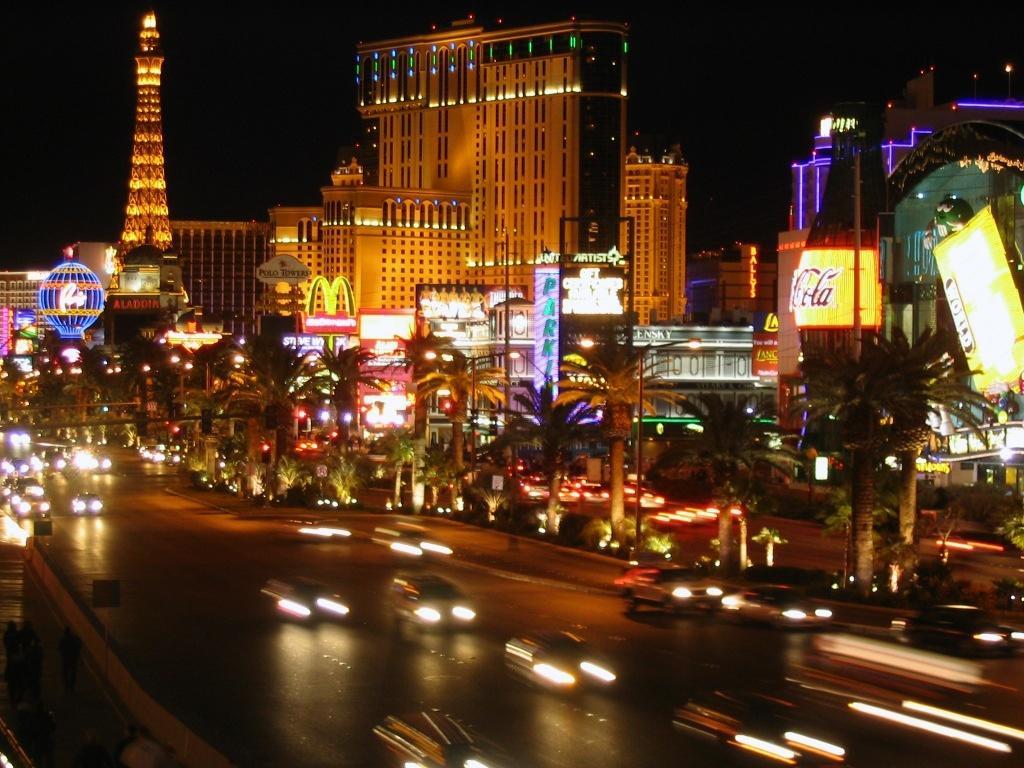Describe this image in one or two sentences. In this image there are cars on a road, in the background there are trees, buildings, boards and there are lights. 